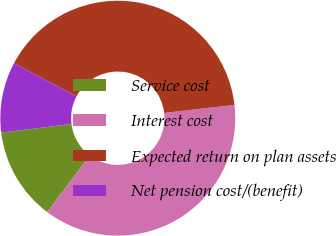Convert chart. <chart><loc_0><loc_0><loc_500><loc_500><pie_chart><fcel>Service cost<fcel>Interest cost<fcel>Expected return on plan assets<fcel>Net pension cost/(benefit)<nl><fcel>12.79%<fcel>37.05%<fcel>40.44%<fcel>9.72%<nl></chart> 